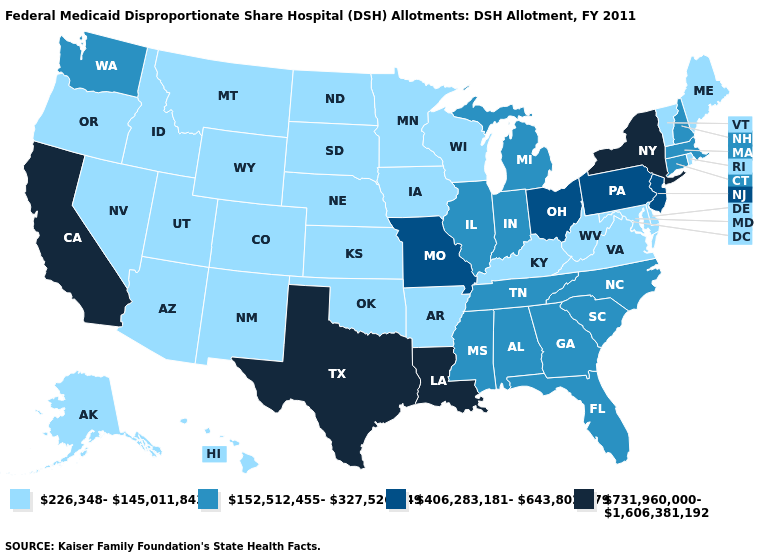Does the map have missing data?
Give a very brief answer. No. Name the states that have a value in the range 731,960,000-1,606,381,192?
Write a very short answer. California, Louisiana, New York, Texas. Does Vermont have the lowest value in the Northeast?
Short answer required. Yes. Does Vermont have the highest value in the USA?
Be succinct. No. What is the highest value in the South ?
Be succinct. 731,960,000-1,606,381,192. Does Washington have the lowest value in the USA?
Be succinct. No. What is the value of Pennsylvania?
Concise answer only. 406,283,181-643,802,579. Name the states that have a value in the range 226,348-145,011,843?
Quick response, please. Alaska, Arizona, Arkansas, Colorado, Delaware, Hawaii, Idaho, Iowa, Kansas, Kentucky, Maine, Maryland, Minnesota, Montana, Nebraska, Nevada, New Mexico, North Dakota, Oklahoma, Oregon, Rhode Island, South Dakota, Utah, Vermont, Virginia, West Virginia, Wisconsin, Wyoming. Name the states that have a value in the range 226,348-145,011,843?
Short answer required. Alaska, Arizona, Arkansas, Colorado, Delaware, Hawaii, Idaho, Iowa, Kansas, Kentucky, Maine, Maryland, Minnesota, Montana, Nebraska, Nevada, New Mexico, North Dakota, Oklahoma, Oregon, Rhode Island, South Dakota, Utah, Vermont, Virginia, West Virginia, Wisconsin, Wyoming. Among the states that border Tennessee , which have the highest value?
Short answer required. Missouri. Does Washington have a lower value than Kentucky?
Be succinct. No. Among the states that border Kansas , does Missouri have the highest value?
Concise answer only. Yes. Does Iowa have the same value as New York?
Quick response, please. No. What is the highest value in states that border South Carolina?
Answer briefly. 152,512,455-327,526,749. What is the lowest value in the USA?
Write a very short answer. 226,348-145,011,843. 